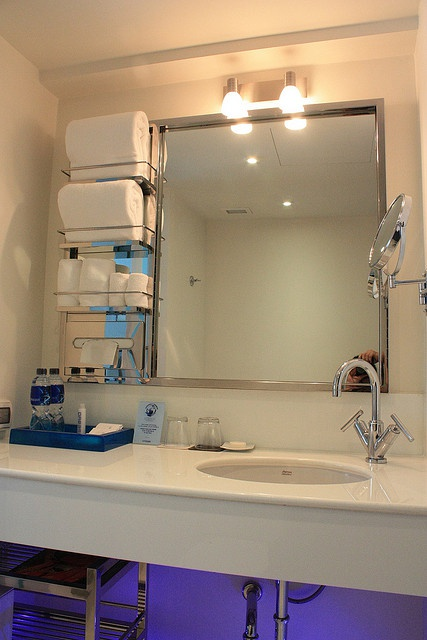Describe the objects in this image and their specific colors. I can see sink in gray and tan tones, bottle in gray, black, and navy tones, bottle in gray, black, and navy tones, cup in gray and tan tones, and cup in gray and tan tones in this image. 